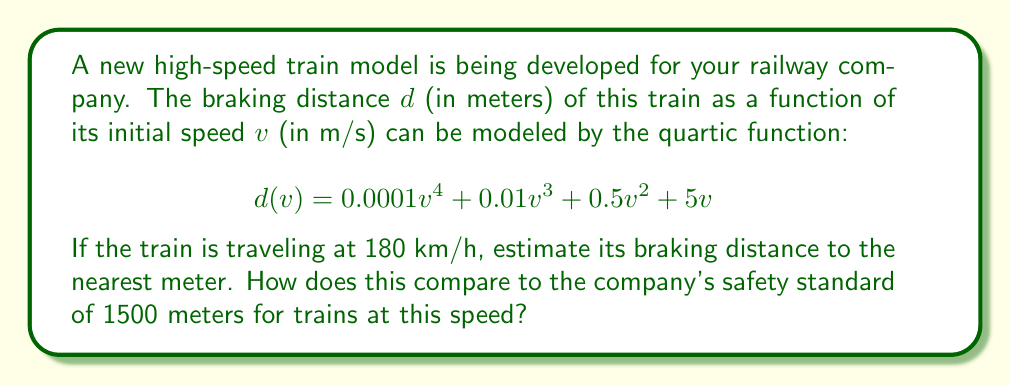Solve this math problem. Let's approach this step-by-step:

1) First, we need to convert the train's speed from km/h to m/s:
   $180 \text{ km/h} = 180 \times \frac{1000}{3600} \text{ m/s} = 50 \text{ m/s}$

2) Now, we can substitute $v = 50$ into our quartic function:

   $$\begin{align}
   d(50) &= 0.0001(50)^4 + 0.01(50)^3 + 0.5(50)^2 + 5(50) \\
   &= 0.0001(6250000) + 0.01(125000) + 0.5(2500) + 250
   \end{align}$$

3) Let's calculate each term:
   - $0.0001(6250000) = 625$
   - $0.01(125000) = 1250$
   - $0.5(2500) = 1250$
   - $250$

4) Sum up all terms:
   $$625 + 1250 + 1250 + 250 = 3375 \text{ meters}$$

5) Rounding to the nearest meter: 3375 meters

6) Comparing to the safety standard:
   3375 meters > 1500 meters

The braking distance significantly exceeds the company's safety standard by 1875 meters.
Answer: 3375 meters; exceeds safety standard by 1875 meters 